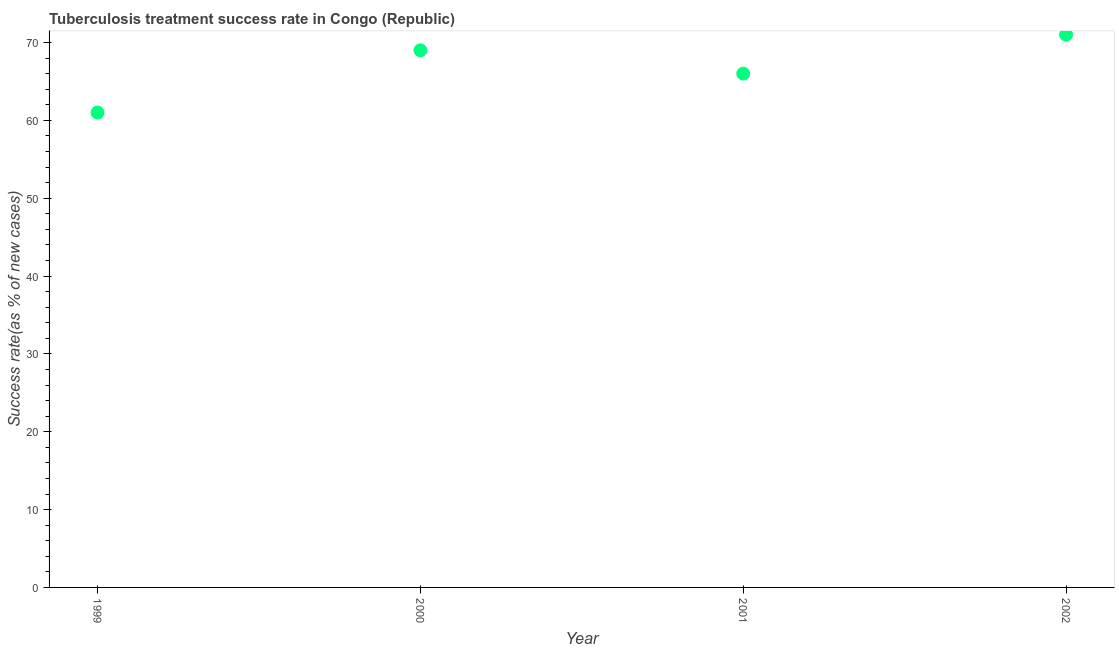What is the tuberculosis treatment success rate in 2000?
Provide a succinct answer. 69. Across all years, what is the maximum tuberculosis treatment success rate?
Your response must be concise. 71. Across all years, what is the minimum tuberculosis treatment success rate?
Provide a succinct answer. 61. What is the sum of the tuberculosis treatment success rate?
Provide a short and direct response. 267. What is the difference between the tuberculosis treatment success rate in 1999 and 2002?
Your answer should be very brief. -10. What is the average tuberculosis treatment success rate per year?
Ensure brevity in your answer.  66.75. What is the median tuberculosis treatment success rate?
Ensure brevity in your answer.  67.5. Do a majority of the years between 2000 and 2002 (inclusive) have tuberculosis treatment success rate greater than 12 %?
Offer a terse response. Yes. What is the ratio of the tuberculosis treatment success rate in 1999 to that in 2002?
Keep it short and to the point. 0.86. Is the tuberculosis treatment success rate in 2000 less than that in 2002?
Offer a terse response. Yes. What is the difference between the highest and the second highest tuberculosis treatment success rate?
Make the answer very short. 2. What is the difference between the highest and the lowest tuberculosis treatment success rate?
Offer a very short reply. 10. Does the tuberculosis treatment success rate monotonically increase over the years?
Your answer should be very brief. No. Does the graph contain any zero values?
Your response must be concise. No. What is the title of the graph?
Your response must be concise. Tuberculosis treatment success rate in Congo (Republic). What is the label or title of the X-axis?
Ensure brevity in your answer.  Year. What is the label or title of the Y-axis?
Your answer should be very brief. Success rate(as % of new cases). What is the Success rate(as % of new cases) in 2000?
Give a very brief answer. 69. What is the Success rate(as % of new cases) in 2001?
Ensure brevity in your answer.  66. What is the difference between the Success rate(as % of new cases) in 1999 and 2000?
Keep it short and to the point. -8. What is the difference between the Success rate(as % of new cases) in 1999 and 2001?
Provide a short and direct response. -5. What is the difference between the Success rate(as % of new cases) in 1999 and 2002?
Give a very brief answer. -10. What is the difference between the Success rate(as % of new cases) in 2000 and 2001?
Offer a terse response. 3. What is the difference between the Success rate(as % of new cases) in 2000 and 2002?
Provide a short and direct response. -2. What is the ratio of the Success rate(as % of new cases) in 1999 to that in 2000?
Your answer should be very brief. 0.88. What is the ratio of the Success rate(as % of new cases) in 1999 to that in 2001?
Your response must be concise. 0.92. What is the ratio of the Success rate(as % of new cases) in 1999 to that in 2002?
Ensure brevity in your answer.  0.86. What is the ratio of the Success rate(as % of new cases) in 2000 to that in 2001?
Make the answer very short. 1.04. What is the ratio of the Success rate(as % of new cases) in 2001 to that in 2002?
Offer a terse response. 0.93. 